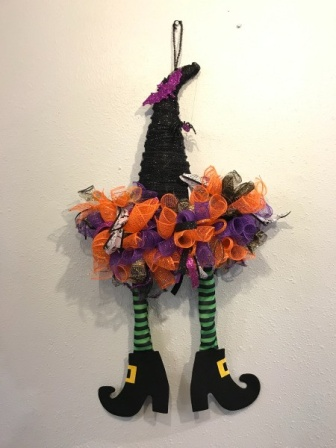If this witch decoration came to life, what kind of mischief might she get into? If this witch decoration suddenly sprung to life, one can imagine a flurry of delightful mischief! She might rattle her silver bells to spook the unsuspecting, rearrange items on shelves with a flick of her hand, or even whip up some magical potions in the kitchen. One could envision her cackling gleefully as she darts around, leaving trails of glitter and enchanted baubles in her wake. The house would become a whimsical scene straight out of a Halloween fairytale as she casts playful spells and concocts bubbling brews from everyday items. What might this decoration contribute to a Halloween party? This lively witch decoration would undoubtedly be a show-stopping piece at any Halloween party. Hanging prominently on a wall, it would catch the eye of every guest, immediately infusing the space with a playful and spooky atmosphere. It could be the centerpiece of a themed photo booth, inspiring guests to take fun and memorable pictures. Additionally, it would serve as excellent inspiration for costume contests, setting the tone for creativity and fun. The decoration also adds a narrative element to the setting, inviting guests to imagine the story of the witch who mistakenly crashed into the wall. Overall, it would enhance the festive ambiance, making the party feel truly magical. 